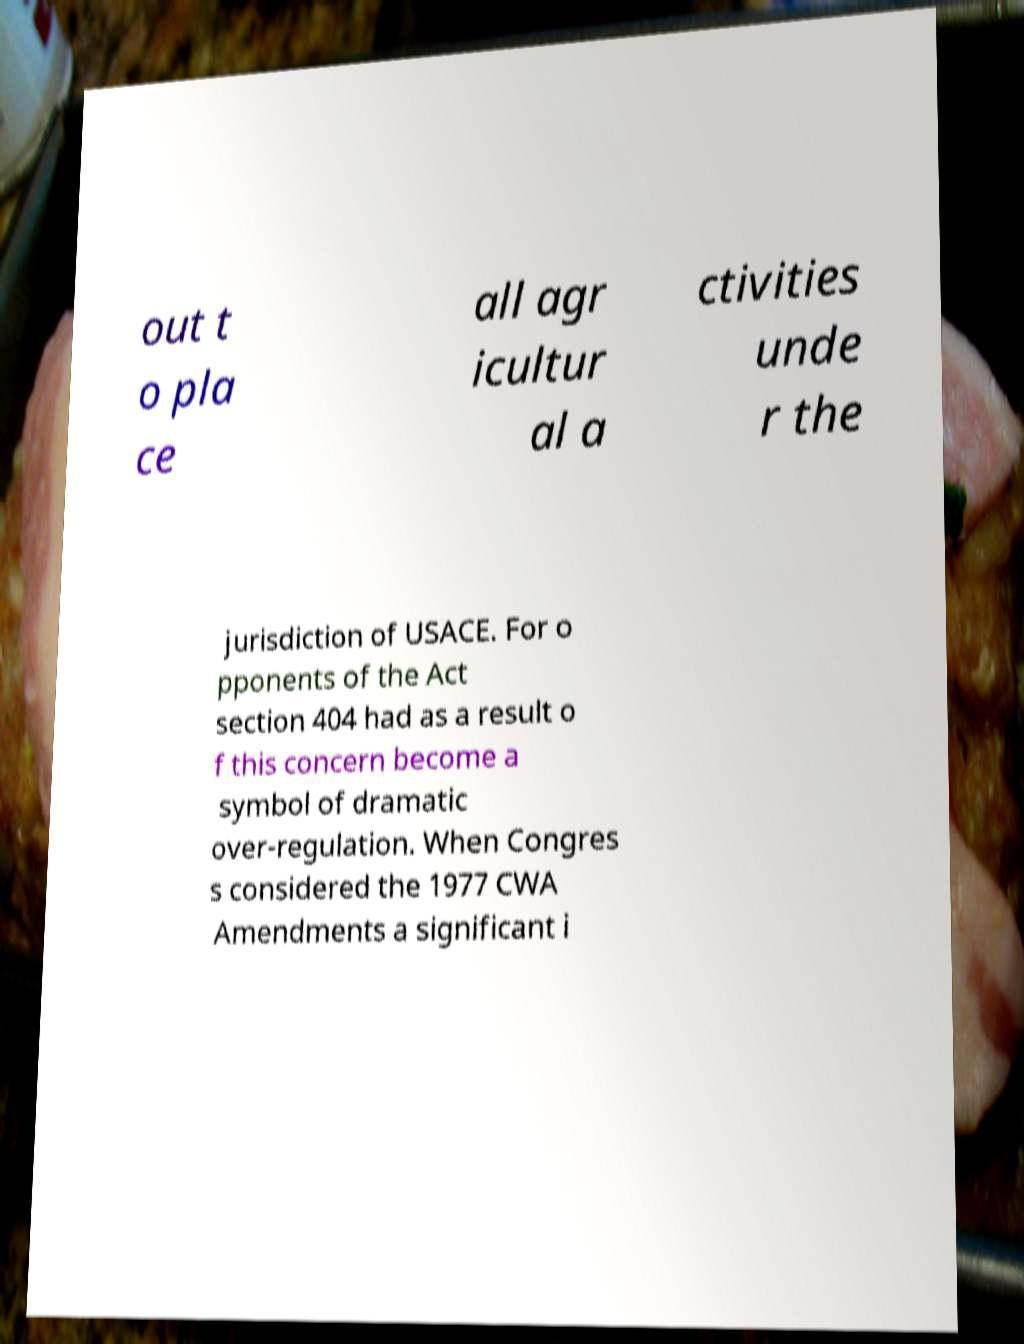For documentation purposes, I need the text within this image transcribed. Could you provide that? out t o pla ce all agr icultur al a ctivities unde r the jurisdiction of USACE. For o pponents of the Act section 404 had as a result o f this concern become a symbol of dramatic over-regulation. When Congres s considered the 1977 CWA Amendments a significant i 